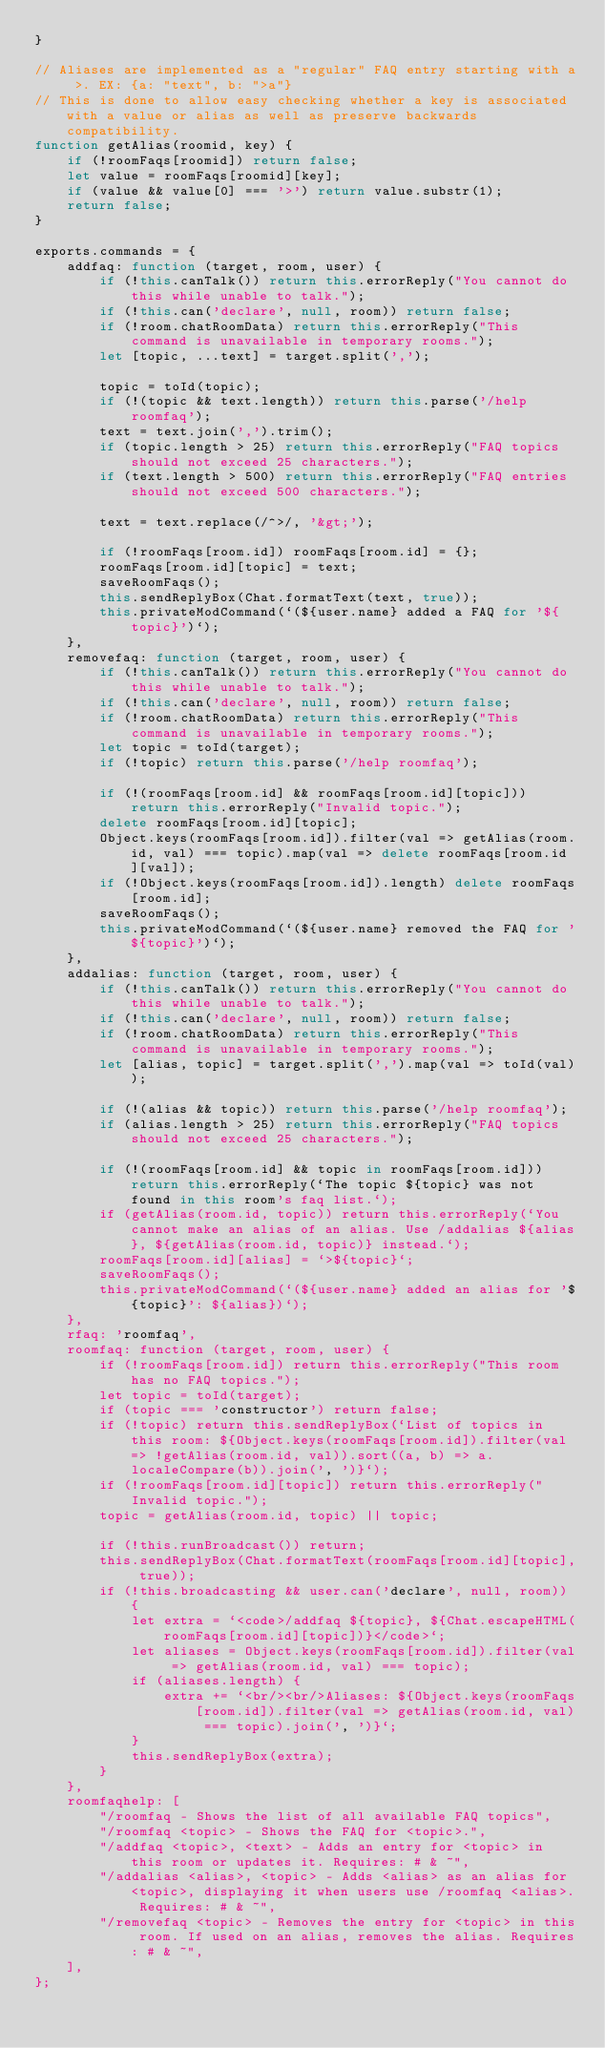<code> <loc_0><loc_0><loc_500><loc_500><_JavaScript_>}

// Aliases are implemented as a "regular" FAQ entry starting with a >. EX: {a: "text", b: ">a"}
// This is done to allow easy checking whether a key is associated with a value or alias as well as preserve backwards compatibility.
function getAlias(roomid, key) {
	if (!roomFaqs[roomid]) return false;
	let value = roomFaqs[roomid][key];
	if (value && value[0] === '>') return value.substr(1);
	return false;
}

exports.commands = {
	addfaq: function (target, room, user) {
		if (!this.canTalk()) return this.errorReply("You cannot do this while unable to talk.");
		if (!this.can('declare', null, room)) return false;
		if (!room.chatRoomData) return this.errorReply("This command is unavailable in temporary rooms.");
		let [topic, ...text] = target.split(',');

		topic = toId(topic);
		if (!(topic && text.length)) return this.parse('/help roomfaq');
		text = text.join(',').trim();
		if (topic.length > 25) return this.errorReply("FAQ topics should not exceed 25 characters.");
		if (text.length > 500) return this.errorReply("FAQ entries should not exceed 500 characters.");

		text = text.replace(/^>/, '&gt;');

		if (!roomFaqs[room.id]) roomFaqs[room.id] = {};
		roomFaqs[room.id][topic] = text;
		saveRoomFaqs();
		this.sendReplyBox(Chat.formatText(text, true));
		this.privateModCommand(`(${user.name} added a FAQ for '${topic}')`);
	},
	removefaq: function (target, room, user) {
		if (!this.canTalk()) return this.errorReply("You cannot do this while unable to talk.");
		if (!this.can('declare', null, room)) return false;
		if (!room.chatRoomData) return this.errorReply("This command is unavailable in temporary rooms.");
		let topic = toId(target);
		if (!topic) return this.parse('/help roomfaq');

		if (!(roomFaqs[room.id] && roomFaqs[room.id][topic])) return this.errorReply("Invalid topic.");
		delete roomFaqs[room.id][topic];
		Object.keys(roomFaqs[room.id]).filter(val => getAlias(room.id, val) === topic).map(val => delete roomFaqs[room.id][val]);
		if (!Object.keys(roomFaqs[room.id]).length) delete roomFaqs[room.id];
		saveRoomFaqs();
		this.privateModCommand(`(${user.name} removed the FAQ for '${topic}')`);
	},
	addalias: function (target, room, user) {
		if (!this.canTalk()) return this.errorReply("You cannot do this while unable to talk.");
		if (!this.can('declare', null, room)) return false;
		if (!room.chatRoomData) return this.errorReply("This command is unavailable in temporary rooms.");
		let [alias, topic] = target.split(',').map(val => toId(val));

		if (!(alias && topic)) return this.parse('/help roomfaq');
		if (alias.length > 25) return this.errorReply("FAQ topics should not exceed 25 characters.");

		if (!(roomFaqs[room.id] && topic in roomFaqs[room.id])) return this.errorReply(`The topic ${topic} was not found in this room's faq list.`);
		if (getAlias(room.id, topic)) return this.errorReply(`You cannot make an alias of an alias. Use /addalias ${alias}, ${getAlias(room.id, topic)} instead.`);
		roomFaqs[room.id][alias] = `>${topic}`;
		saveRoomFaqs();
		this.privateModCommand(`(${user.name} added an alias for '${topic}': ${alias})`);
	},
	rfaq: 'roomfaq',
	roomfaq: function (target, room, user) {
		if (!roomFaqs[room.id]) return this.errorReply("This room has no FAQ topics.");
		let topic = toId(target);
		if (topic === 'constructor') return false;
		if (!topic) return this.sendReplyBox(`List of topics in this room: ${Object.keys(roomFaqs[room.id]).filter(val => !getAlias(room.id, val)).sort((a, b) => a.localeCompare(b)).join(', ')}`);
		if (!roomFaqs[room.id][topic]) return this.errorReply("Invalid topic.");
		topic = getAlias(room.id, topic) || topic;

		if (!this.runBroadcast()) return;
		this.sendReplyBox(Chat.formatText(roomFaqs[room.id][topic], true));
		if (!this.broadcasting && user.can('declare', null, room)) {
			let extra = `<code>/addfaq ${topic}, ${Chat.escapeHTML(roomFaqs[room.id][topic])}</code>`;
			let aliases = Object.keys(roomFaqs[room.id]).filter(val => getAlias(room.id, val) === topic);
			if (aliases.length) {
				extra += `<br/><br/>Aliases: ${Object.keys(roomFaqs[room.id]).filter(val => getAlias(room.id, val) === topic).join(', ')}`;
			}
			this.sendReplyBox(extra);
		}
	},
	roomfaqhelp: [
		"/roomfaq - Shows the list of all available FAQ topics",
		"/roomfaq <topic> - Shows the FAQ for <topic>.",
		"/addfaq <topic>, <text> - Adds an entry for <topic> in this room or updates it. Requires: # & ~",
		"/addalias <alias>, <topic> - Adds <alias> as an alias for <topic>, displaying it when users use /roomfaq <alias>. Requires: # & ~",
		"/removefaq <topic> - Removes the entry for <topic> in this room. If used on an alias, removes the alias. Requires: # & ~",
	],
};
</code> 